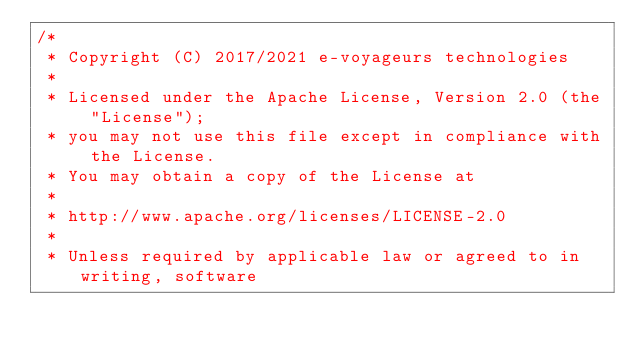Convert code to text. <code><loc_0><loc_0><loc_500><loc_500><_Kotlin_>/*
 * Copyright (C) 2017/2021 e-voyageurs technologies
 *
 * Licensed under the Apache License, Version 2.0 (the "License");
 * you may not use this file except in compliance with the License.
 * You may obtain a copy of the License at
 *
 * http://www.apache.org/licenses/LICENSE-2.0
 *
 * Unless required by applicable law or agreed to in writing, software</code> 